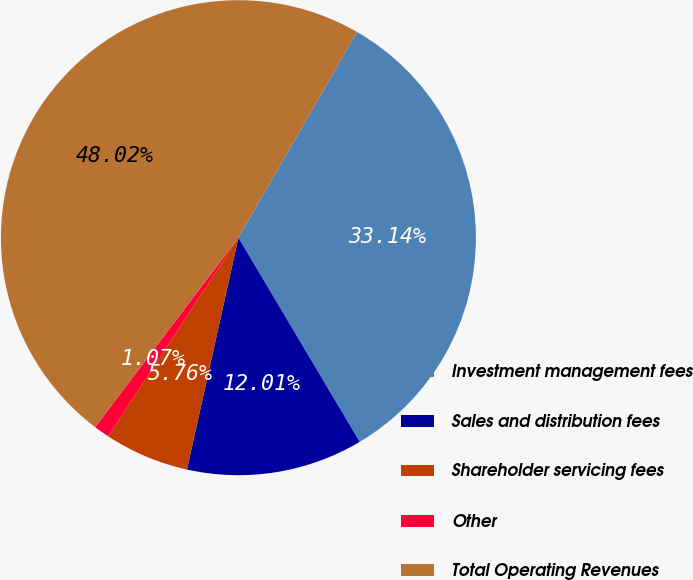<chart> <loc_0><loc_0><loc_500><loc_500><pie_chart><fcel>Investment management fees<fcel>Sales and distribution fees<fcel>Shareholder servicing fees<fcel>Other<fcel>Total Operating Revenues<nl><fcel>33.14%<fcel>12.01%<fcel>5.76%<fcel>1.07%<fcel>48.02%<nl></chart> 